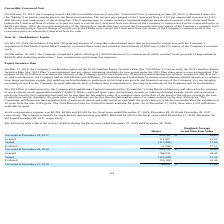According to Chefs Wharehouse's financial document, What is the number of shares that are Unvested at December 29, 2017? According to the financial document, 329,761. The relevant text states: "Unvested at December 29, 2017 329,761 $ 16.69..." Also, What is the Stock compensation expense for the fiscal years ended December 27, 2019, December 28, 2018 and December 29, 2017, respectively? The document contains multiple relevant values: $4,399, $4,094, $3,018. From the document: "vailable for grant. Stock compensation expense was $4,399, $4,094 and $3,018 for the fiscal years ended December 27, 2019, December 28, 2018 and Decem..." Also, When did the Company's stockholders approve the 2019 Omnibus Equity Incentive Plan? According to the financial document, May 17, 2019. The relevant text states: "Equity Incentive Plan On May 17, 2019, the Company’s stockholders approved the 2019 Omnibus Equity Incentive Plan (the “2019 Plan”). Conc..." Also, can you calculate: What is the average Stock compensation expense for the fiscal years ended December 27, 2019, December 28, 2018 and December 29, 2017? To answer this question, I need to perform calculations using the financial data. The calculation is: (4,399+ 4,094+ 3,018)/3, which equals 3837. This is based on the information: "ilable for grant. Stock compensation expense was $4,399, $4,094 and $3,018 for the fiscal years ended December 27, 2019, December 28, 2018 and December 29, tock compensation expense was $4,399, $4,094..." The key data points involved are: 3,018, 4,094, 4,399. Also, can you calculate: What is the change in the number of unvested shares between December 29, 2017 and December 28, 2018? Based on the calculation: 526,730-329,761, the result is 196969. This is based on the information: "Unvested at December 28, 2018 526,730 $ 20.60 Unvested at December 29, 2017 329,761 $ 16.69..." The key data points involved are: 329,761, 526,730. Also, can you calculate: What is the average fair value of RSAs vested during the fiscal years ended December 27, 2019, December 28, 2018 and December 29, 2017? To answer this question, I need to perform calculations using the financial data. The calculation is: (3,742+ 2,936+ 1,703)/3, which equals 2793.67. The key data points involved are: 1,703, 2,936, 3,742. 